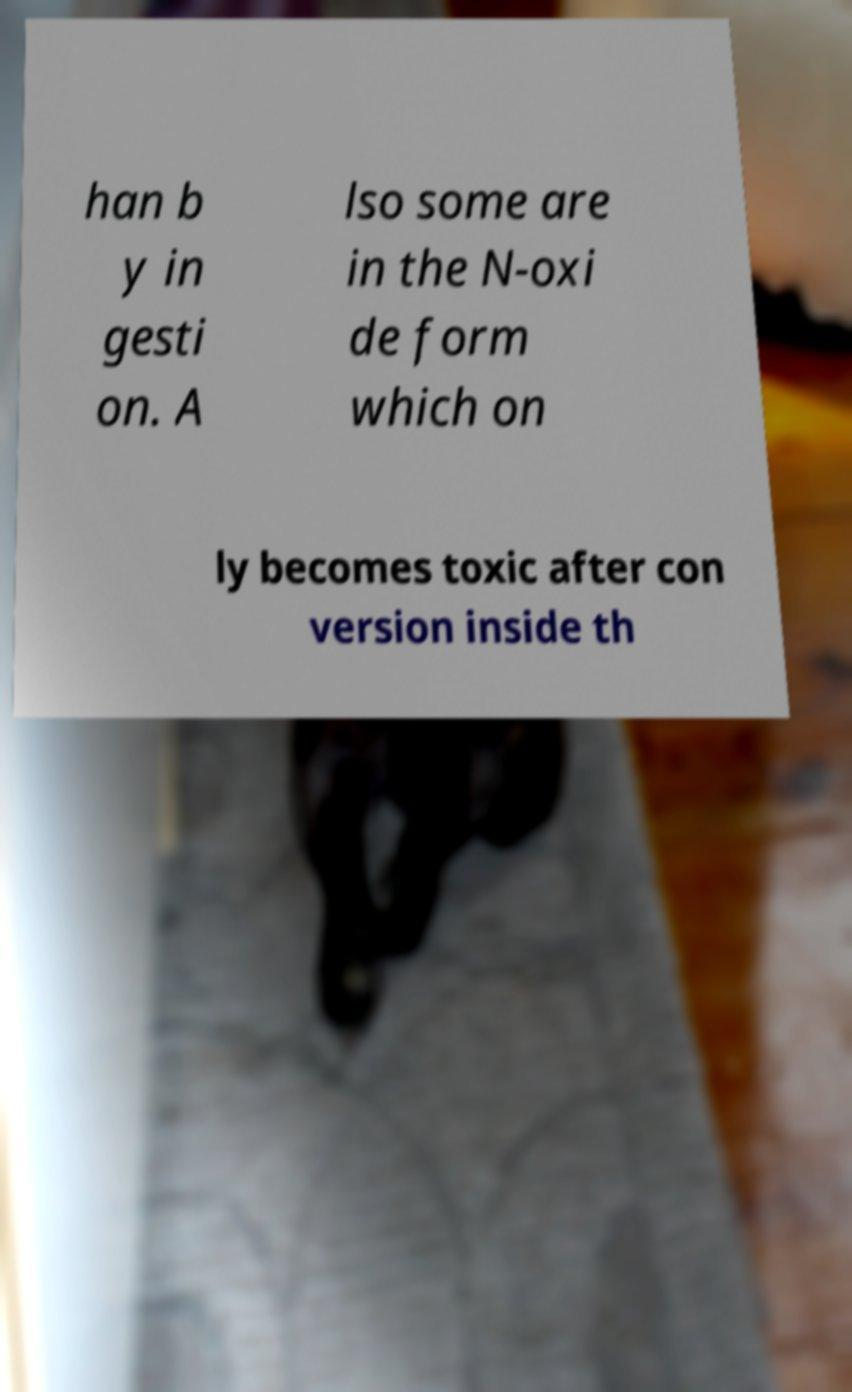Could you assist in decoding the text presented in this image and type it out clearly? han b y in gesti on. A lso some are in the N-oxi de form which on ly becomes toxic after con version inside th 